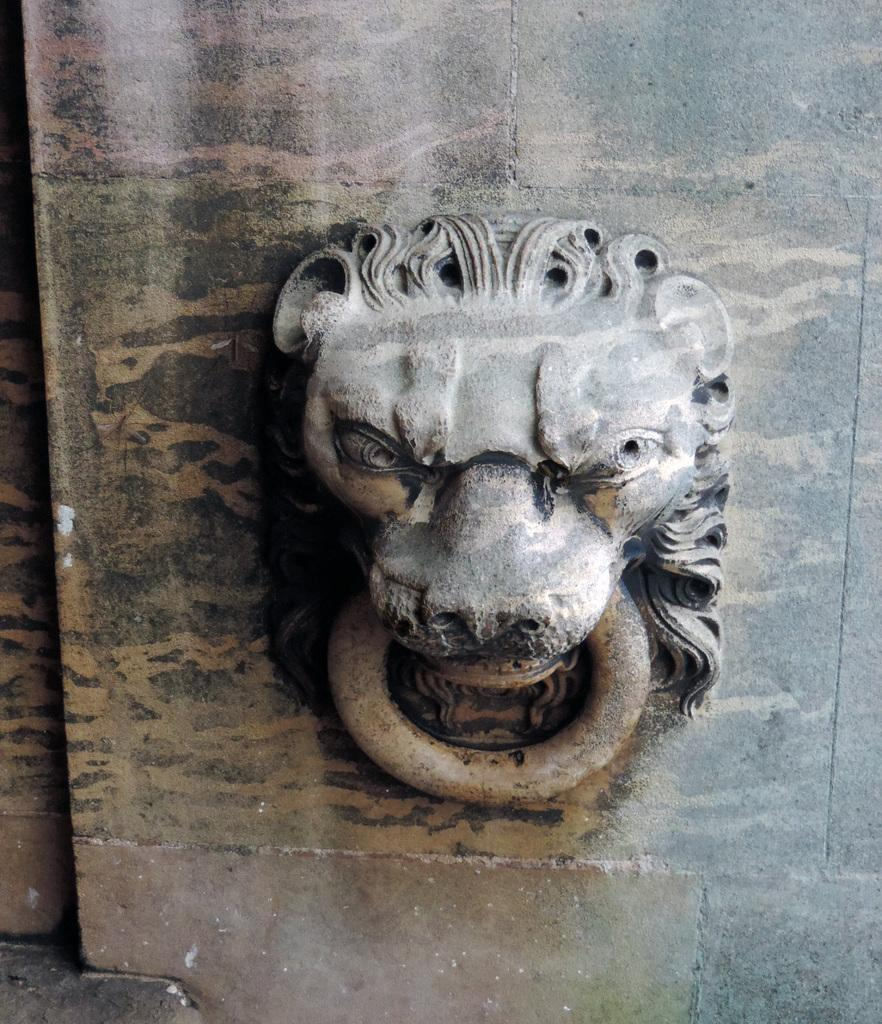What type of door knocker is featured in the image? There is a lion mouth door knocker in the image. What is the door knocker attached to? The door knocker is attached to an object, but the specific object is not mentioned in the provided facts. How many dolls are sitting on the blade in the image? There is no blade or dolls present in the image; it features a lion mouth door knocker. 